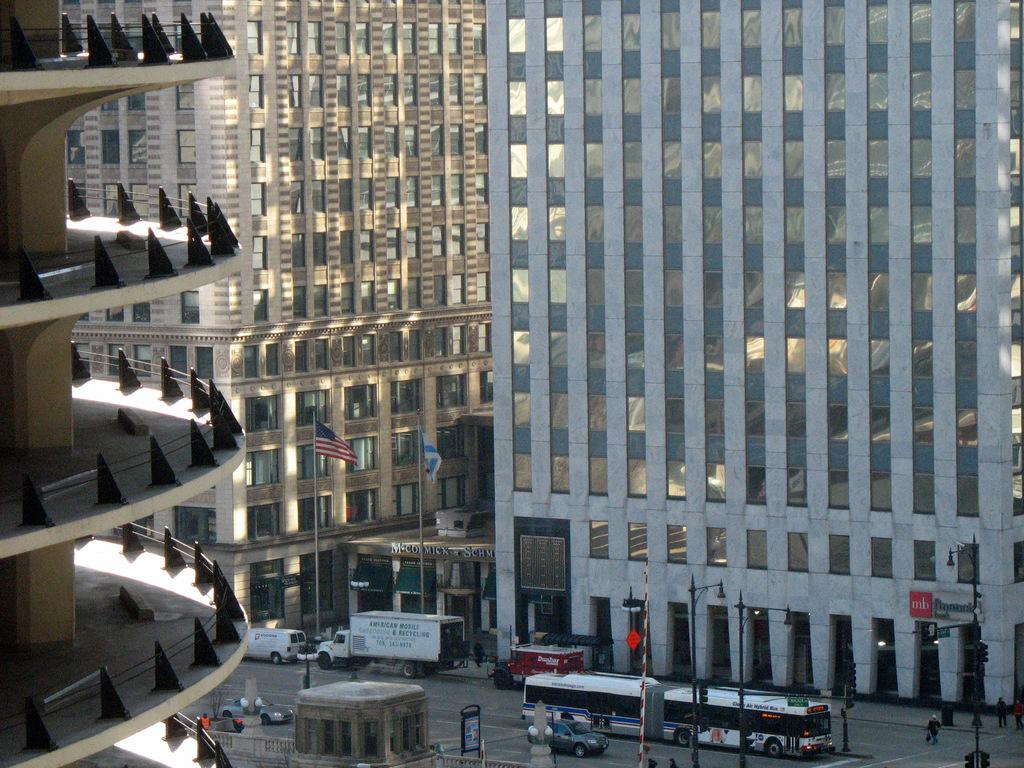What type of structures can be seen in the image? There are buildings in the image. What additional elements are present in the image? There are flags, a road, vehicles, poles, traffic lights, and people visible in the image. Can you describe the road in the image? The road is at the bottom of the image, and vehicles are visible on it. What might be used to control traffic in the image? Traffic lights are present in the image. Are there any people visible in the image? Yes, people are visible in the image. Can you see any ghosts in the image? There are no ghosts present in the image. What type of home is visible in the image? There is no specific home mentioned in the image; it features buildings, roads, and other elements. Where might someone find a pocket in the image? There is no mention of a pocket in the image; it focuses on buildings, flags, roads, vehicles, poles, traffic lights, and people. 